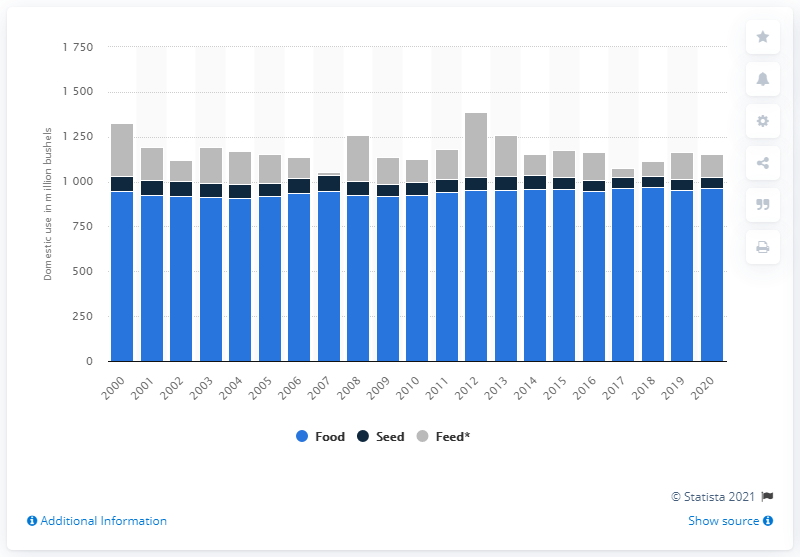Indicate a few pertinent items in this graphic. In 2019, 955 bushels of wheat were used for food. Sixty bushels of wheat were used as seed. 